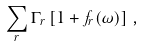Convert formula to latex. <formula><loc_0><loc_0><loc_500><loc_500>\sum _ { r } \Gamma _ { r } \left [ 1 + f _ { r } ( \omega ) \right ] \, ,</formula> 